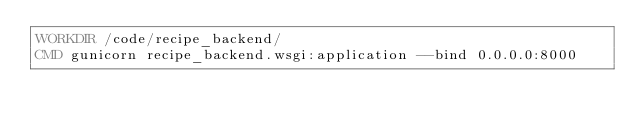<code> <loc_0><loc_0><loc_500><loc_500><_Dockerfile_>WORKDIR /code/recipe_backend/
CMD gunicorn recipe_backend.wsgi:application --bind 0.0.0.0:8000</code> 